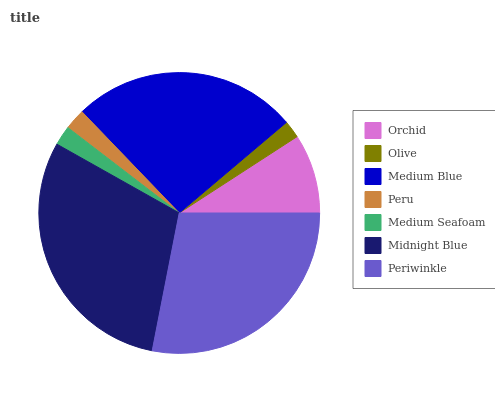Is Olive the minimum?
Answer yes or no. Yes. Is Midnight Blue the maximum?
Answer yes or no. Yes. Is Medium Blue the minimum?
Answer yes or no. No. Is Medium Blue the maximum?
Answer yes or no. No. Is Medium Blue greater than Olive?
Answer yes or no. Yes. Is Olive less than Medium Blue?
Answer yes or no. Yes. Is Olive greater than Medium Blue?
Answer yes or no. No. Is Medium Blue less than Olive?
Answer yes or no. No. Is Orchid the high median?
Answer yes or no. Yes. Is Orchid the low median?
Answer yes or no. Yes. Is Periwinkle the high median?
Answer yes or no. No. Is Midnight Blue the low median?
Answer yes or no. No. 